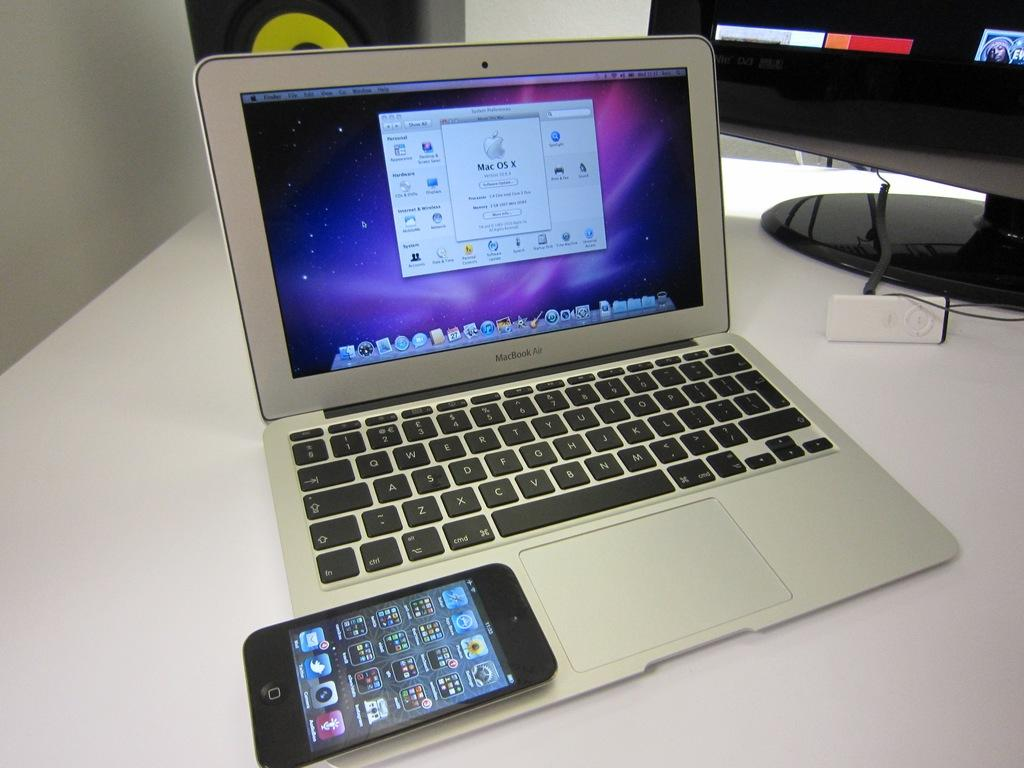<image>
Summarize the visual content of the image. Cellphone on top of a Macbook Air showing MAC OS X on the screen. 